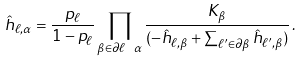Convert formula to latex. <formula><loc_0><loc_0><loc_500><loc_500>\hat { h } _ { \ell , \alpha } = \frac { p _ { \ell } } { 1 - p _ { \ell } } \prod _ { \beta \in \partial \ell \ \alpha } \frac { K _ { \beta } } { ( - \hat { h } _ { \ell , \beta } + \sum _ { \ell ^ { \prime } \in \partial \beta } \hat { h } _ { \ell ^ { \prime } , \beta } ) } \, .</formula> 